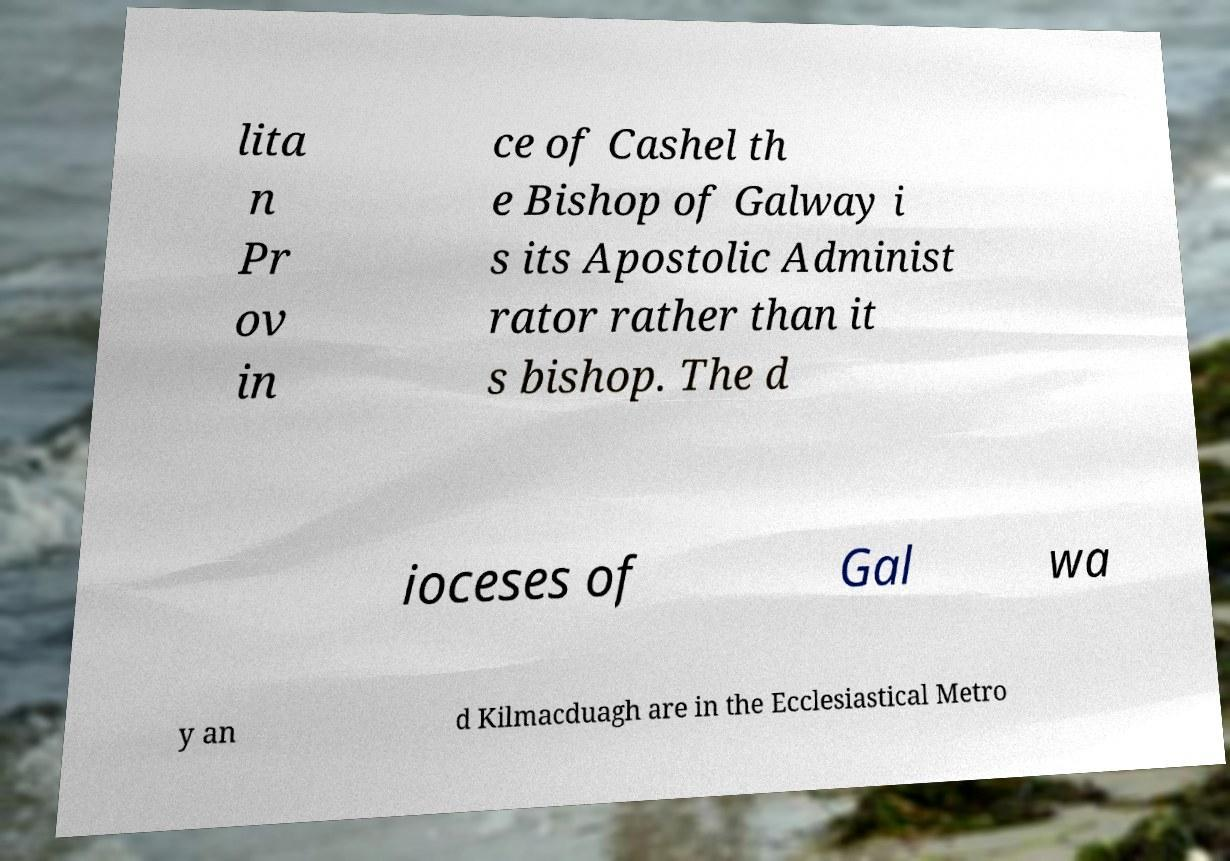Can you read and provide the text displayed in the image?This photo seems to have some interesting text. Can you extract and type it out for me? lita n Pr ov in ce of Cashel th e Bishop of Galway i s its Apostolic Administ rator rather than it s bishop. The d ioceses of Gal wa y an d Kilmacduagh are in the Ecclesiastical Metro 